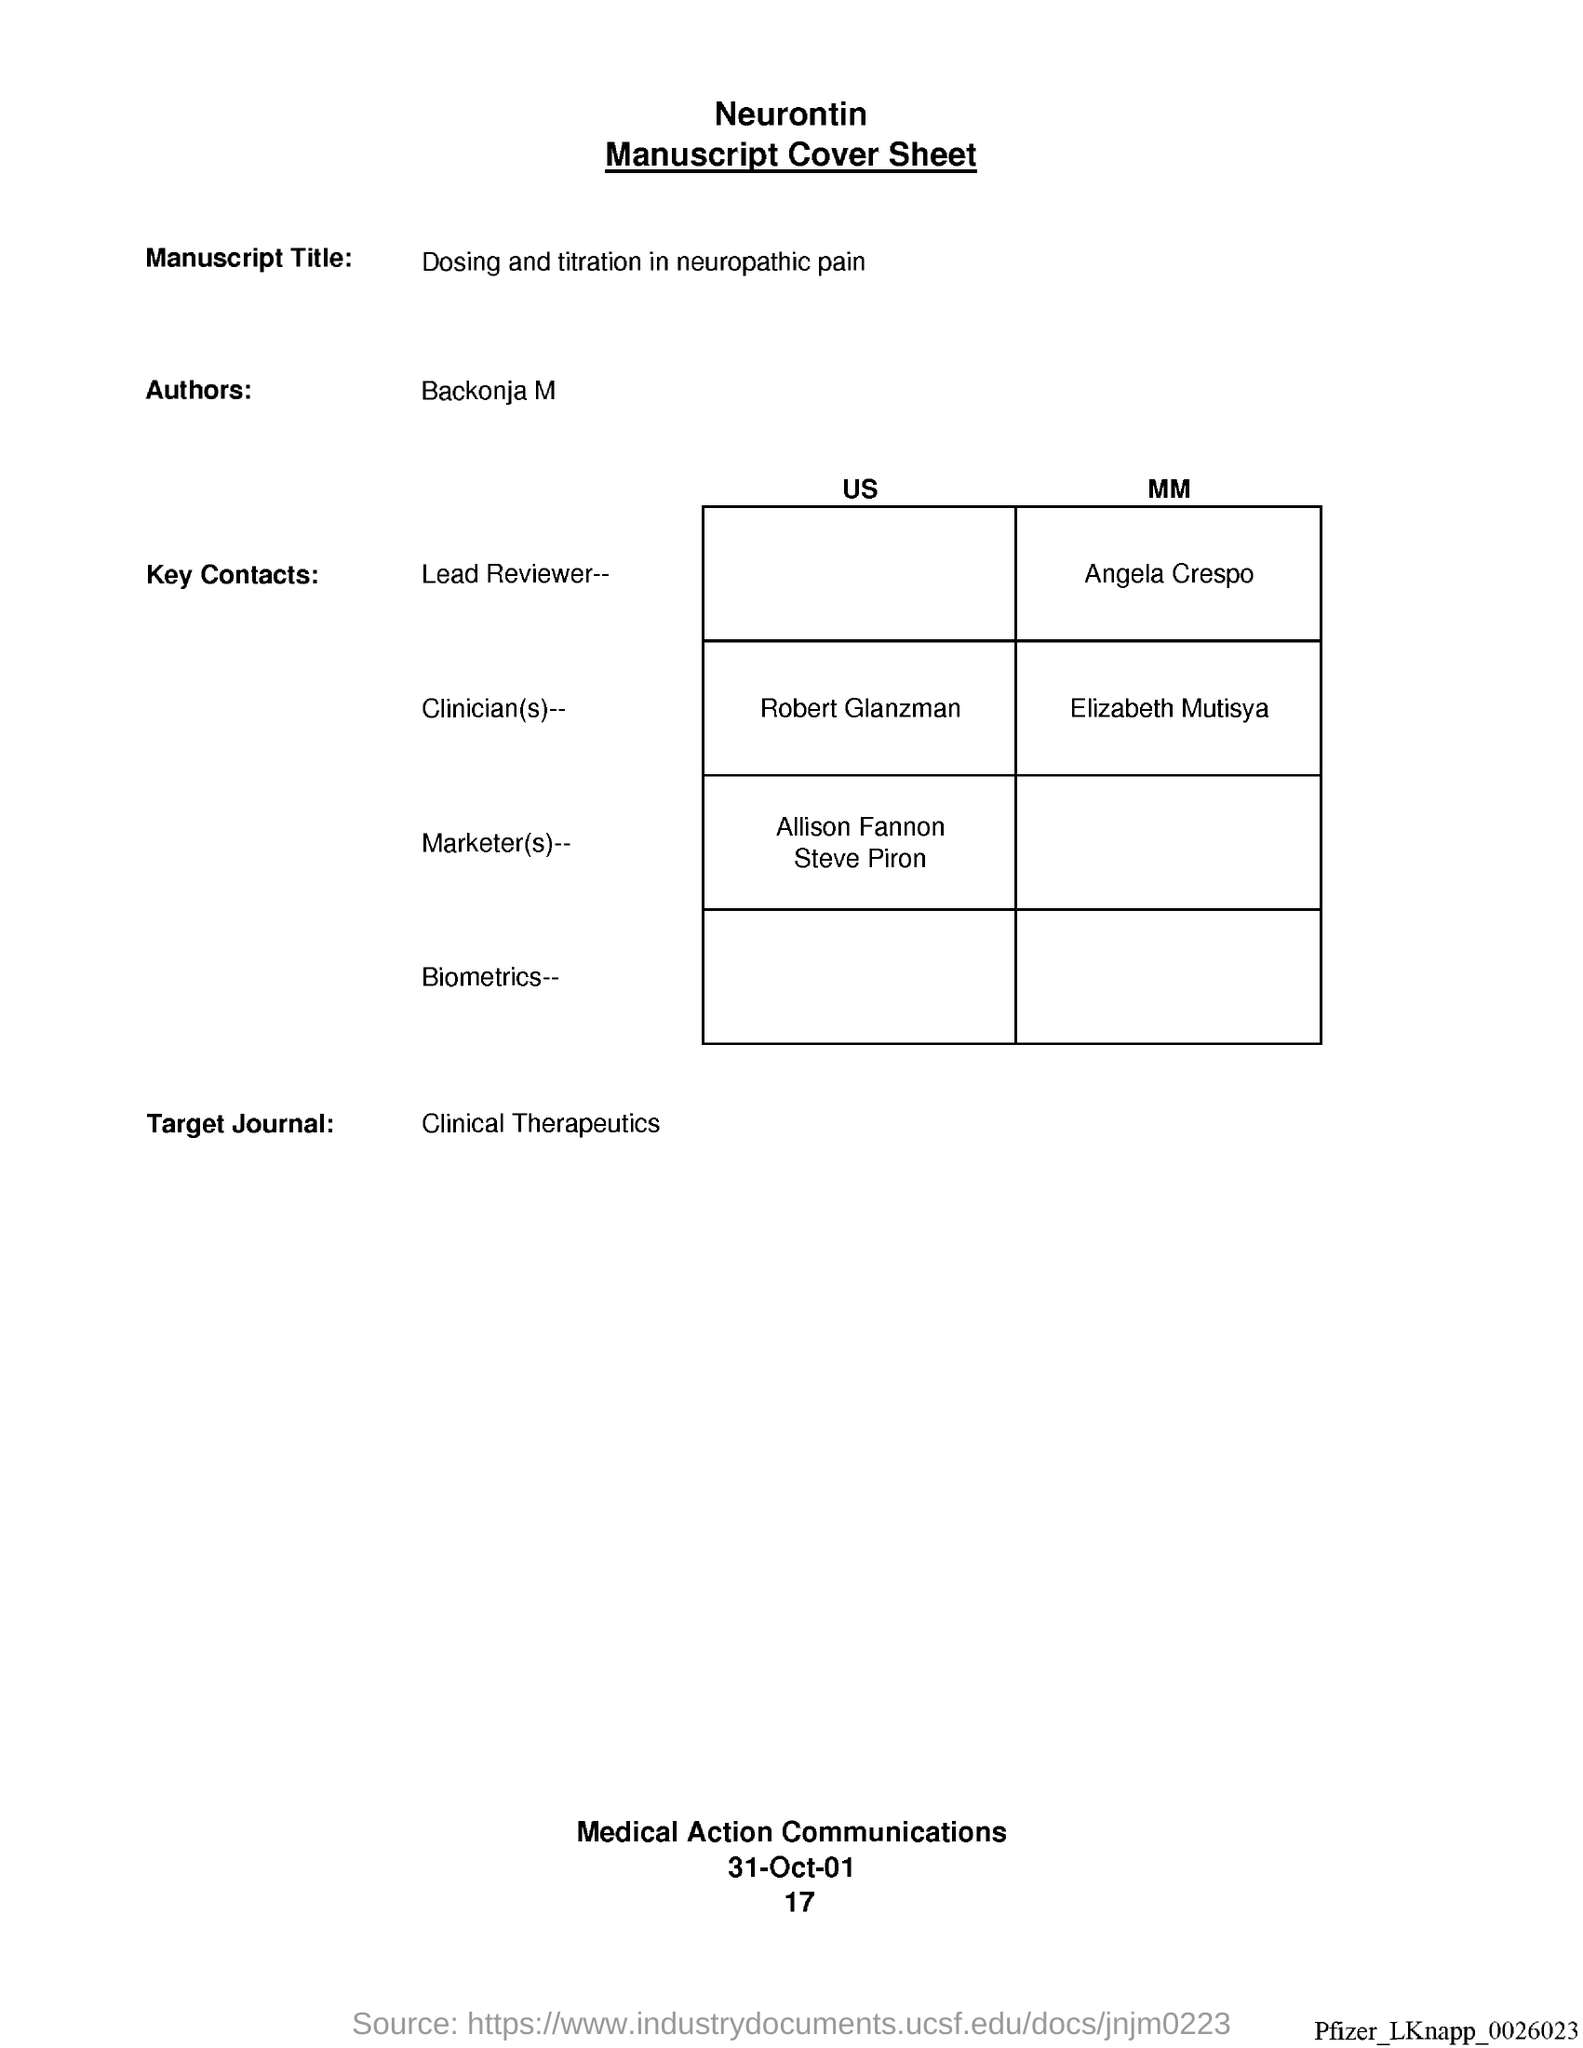Give some essential details in this illustration. The manuscript title is 'Dosing and Titration in Neuropathic Pain.' The Target Journal is "Clinical Therapeutics. The author is Backonja M.. 